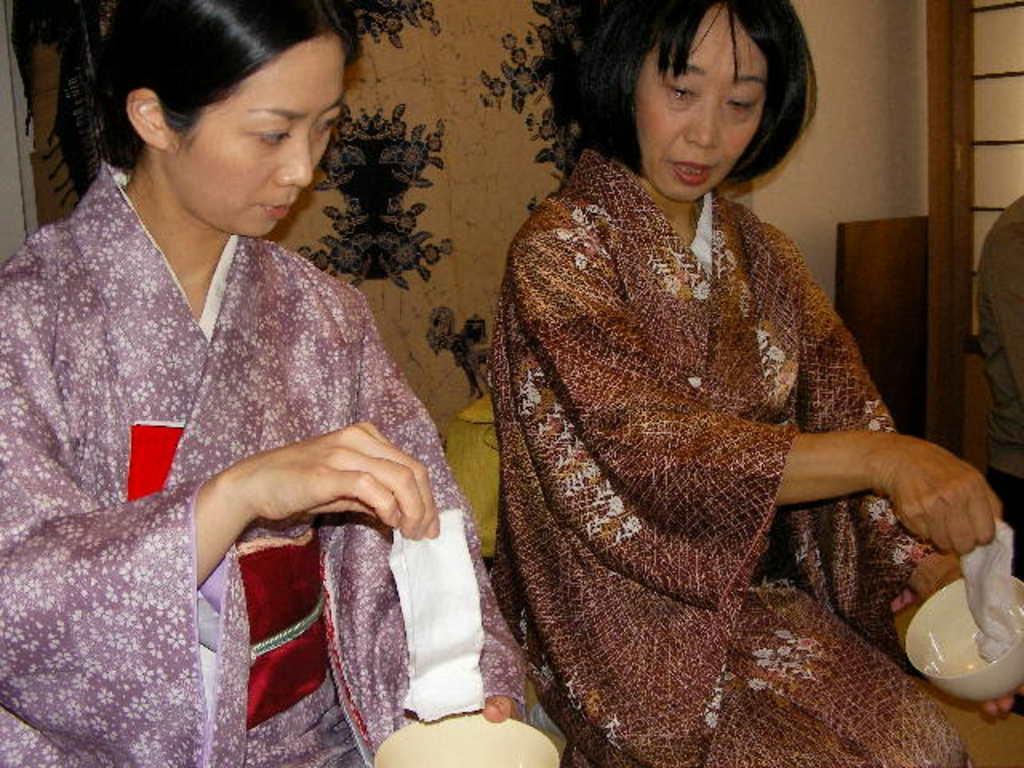In one or two sentences, can you explain what this image depicts? In the front of the image I can see people. Among them two people are holding bowls with one hand and holding an object with the other hand. In the background of the image there is a wall and objects. 